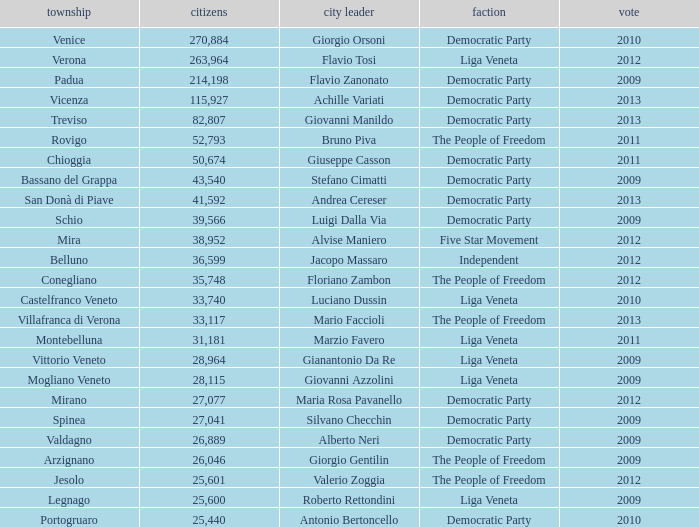What party was achille variati afilliated with? Democratic Party. 